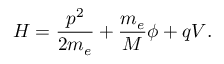Convert formula to latex. <formula><loc_0><loc_0><loc_500><loc_500>H = \frac { p ^ { 2 } } { 2 m _ { e } } + \frac { m _ { e } } { M } \phi + q V .</formula> 